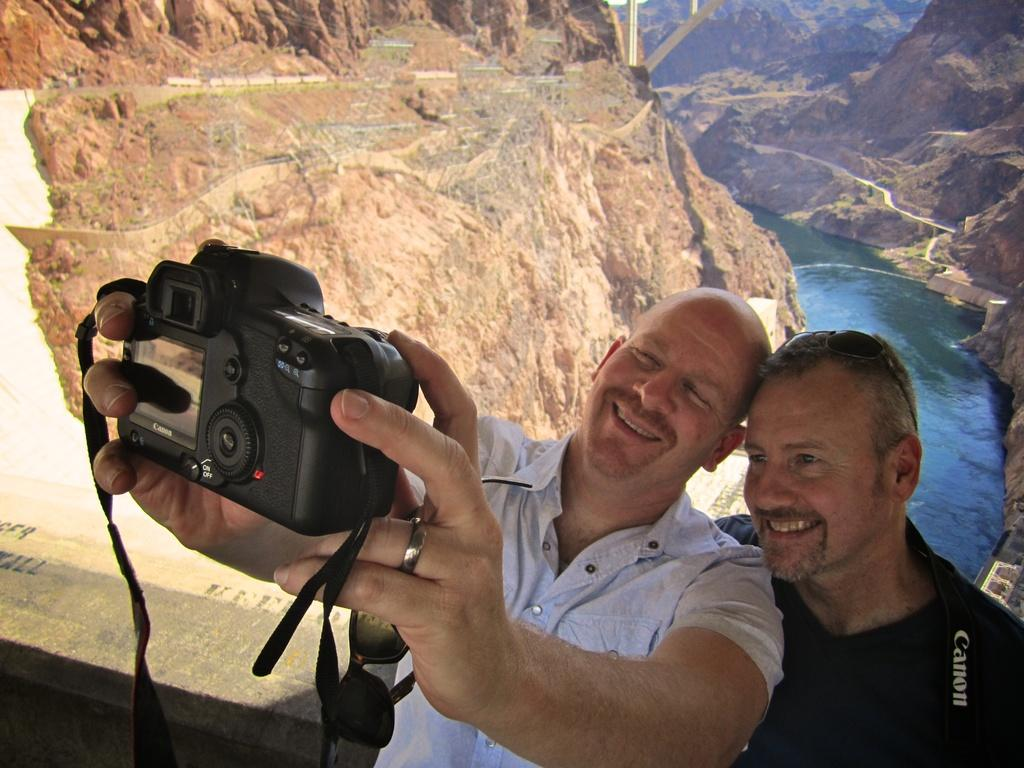How many people are in the image? There are two persons in the image. What are the persons doing in the image? The persons are standing and clicking their photograph in a camera. What is the facial expression of the persons in the image? The persons are smiling in the image. What type of power source is visible in the image? There is no power source visible in the image. Are the persons wearing masks in the image? No, the persons are not wearing masks in the image. 